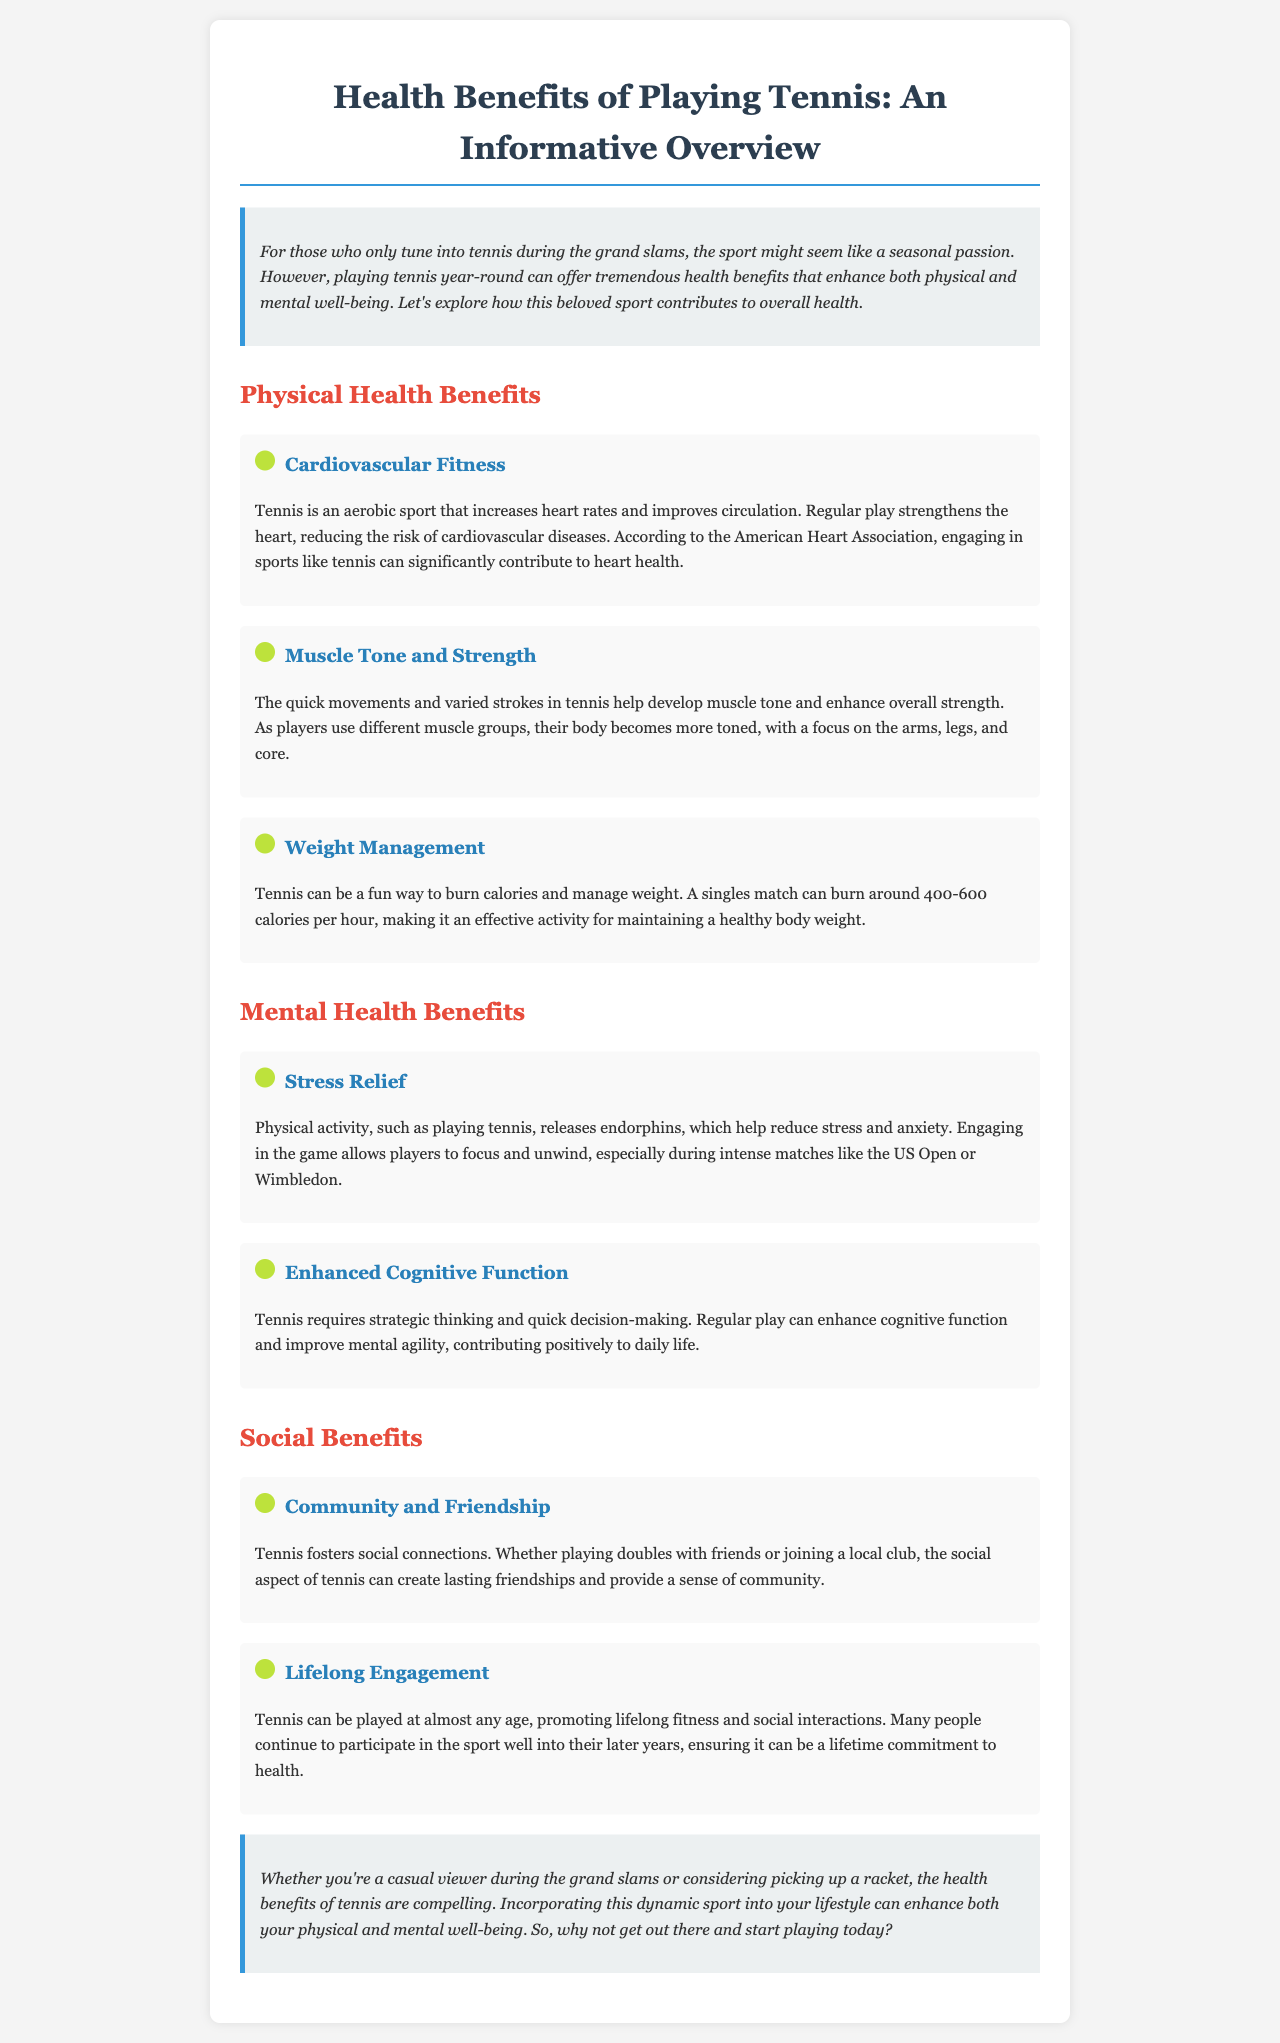what is the main topic of the newsletter? The main topic of the newsletter is the health benefits of playing tennis, focusing on physical and mental well-being.
Answer: health benefits of playing tennis how many calories can a singles match burn per hour? The document states that a singles match can burn around 400-600 calories per hour.
Answer: 400-600 calories which organization is mentioned in relation to heart health? The American Heart Association is mentioned in relation to heart health in the document.
Answer: American Heart Association what benefit does tennis provide for cognitive function? Tennis enhances cognitive function by requiring strategic thinking and quick decision-making.
Answer: enhanced cognitive function what are the two main categories of health benefits discussed? The two main categories of health benefits discussed are physical health benefits and mental health benefits.
Answer: physical and mental health benefits what is a social benefit of playing tennis? One social benefit of playing tennis is the fostering of community and friendship among players.
Answer: community and friendship how does tennis help with stress relief? Tennis helps with stress relief by releasing endorphins that reduce stress and anxiety.
Answer: releases endorphins what age group can participate in tennis? The document states that tennis can be played at almost any age.
Answer: almost any age 